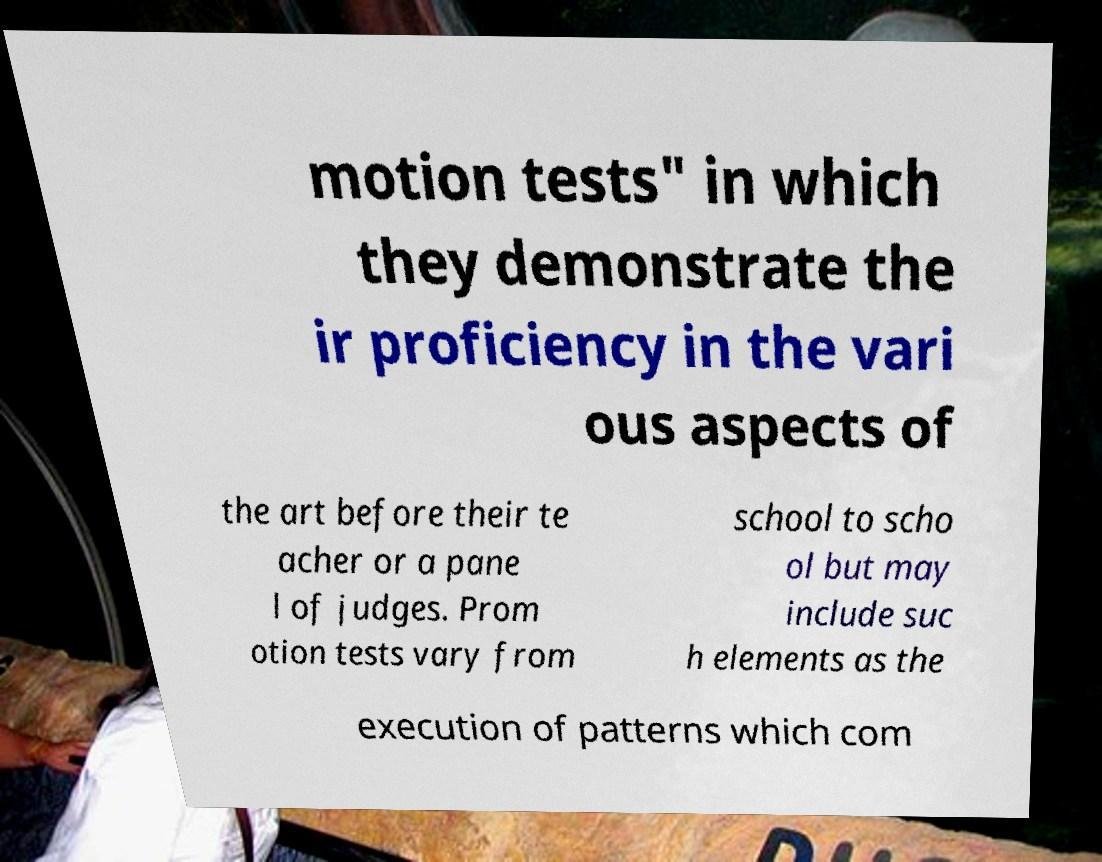Please identify and transcribe the text found in this image. motion tests" in which they demonstrate the ir proficiency in the vari ous aspects of the art before their te acher or a pane l of judges. Prom otion tests vary from school to scho ol but may include suc h elements as the execution of patterns which com 